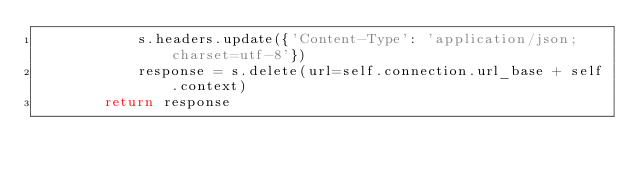<code> <loc_0><loc_0><loc_500><loc_500><_Python_>            s.headers.update({'Content-Type': 'application/json;charset=utf-8'})
            response = s.delete(url=self.connection.url_base + self.context)
        return response
</code> 